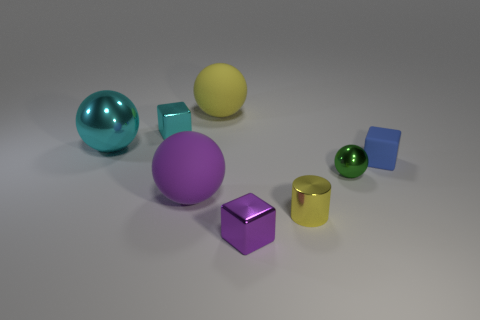There is a small green object that is the same material as the cyan sphere; what is its shape?
Offer a terse response. Sphere. Does the rubber thing behind the small blue thing have the same shape as the big cyan metallic object?
Make the answer very short. Yes. How many yellow objects are rubber blocks or big shiny objects?
Provide a short and direct response. 0. Are there an equal number of small yellow shiny cylinders on the right side of the green shiny object and big yellow balls that are in front of the purple matte sphere?
Give a very brief answer. Yes. What color is the matte ball that is behind the metallic cube to the left of the big sphere behind the cyan block?
Your response must be concise. Yellow. Is there any other thing of the same color as the cylinder?
Keep it short and to the point. Yes. There is a thing that is the same color as the small cylinder; what is its shape?
Give a very brief answer. Sphere. How big is the yellow thing that is behind the big purple object?
Your answer should be compact. Large. What shape is the purple thing that is the same size as the yellow metallic object?
Ensure brevity in your answer.  Cube. Do the large thing that is behind the tiny cyan thing and the cylinder that is in front of the matte block have the same material?
Offer a very short reply. No. 